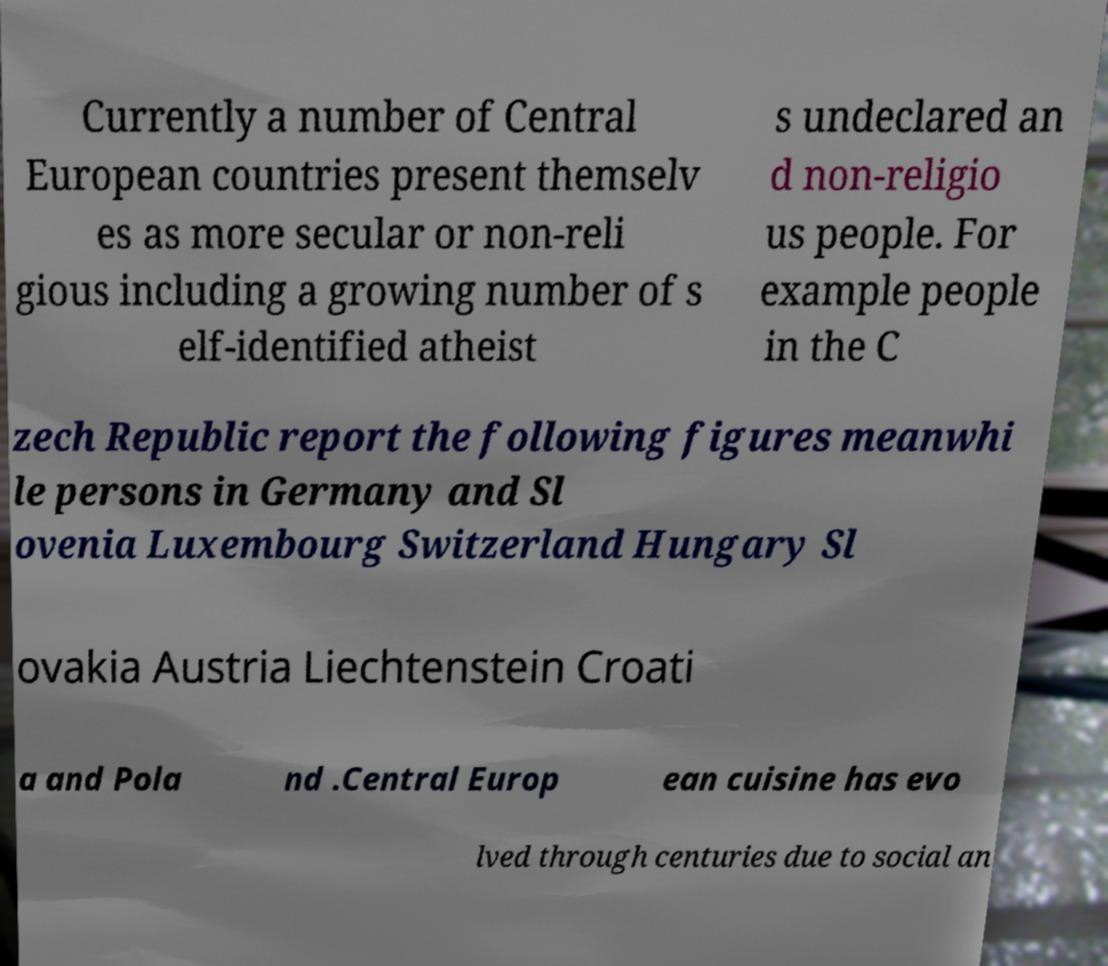Can you accurately transcribe the text from the provided image for me? Currently a number of Central European countries present themselv es as more secular or non-reli gious including a growing number of s elf-identified atheist s undeclared an d non-religio us people. For example people in the C zech Republic report the following figures meanwhi le persons in Germany and Sl ovenia Luxembourg Switzerland Hungary Sl ovakia Austria Liechtenstein Croati a and Pola nd .Central Europ ean cuisine has evo lved through centuries due to social an 